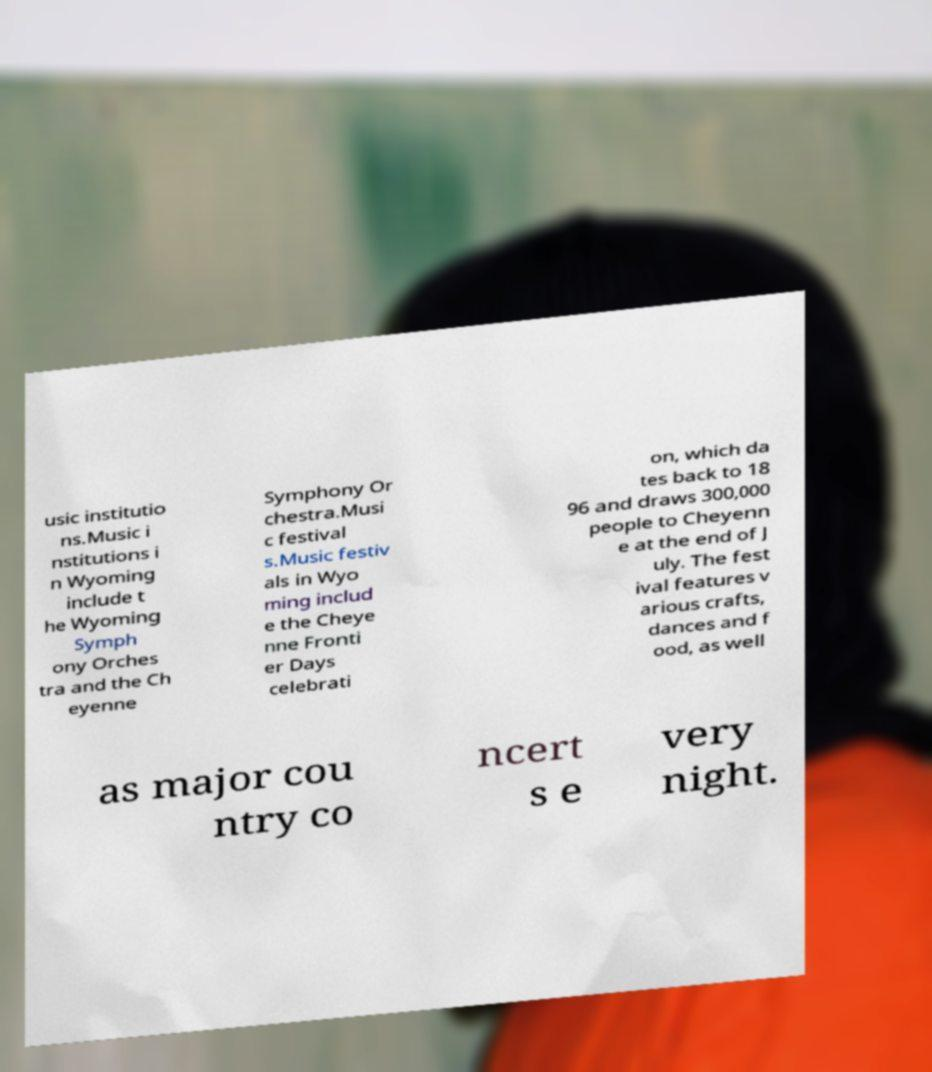Can you accurately transcribe the text from the provided image for me? usic institutio ns.Music i nstitutions i n Wyoming include t he Wyoming Symph ony Orches tra and the Ch eyenne Symphony Or chestra.Musi c festival s.Music festiv als in Wyo ming includ e the Cheye nne Fronti er Days celebrati on, which da tes back to 18 96 and draws 300,000 people to Cheyenn e at the end of J uly. The fest ival features v arious crafts, dances and f ood, as well as major cou ntry co ncert s e very night. 